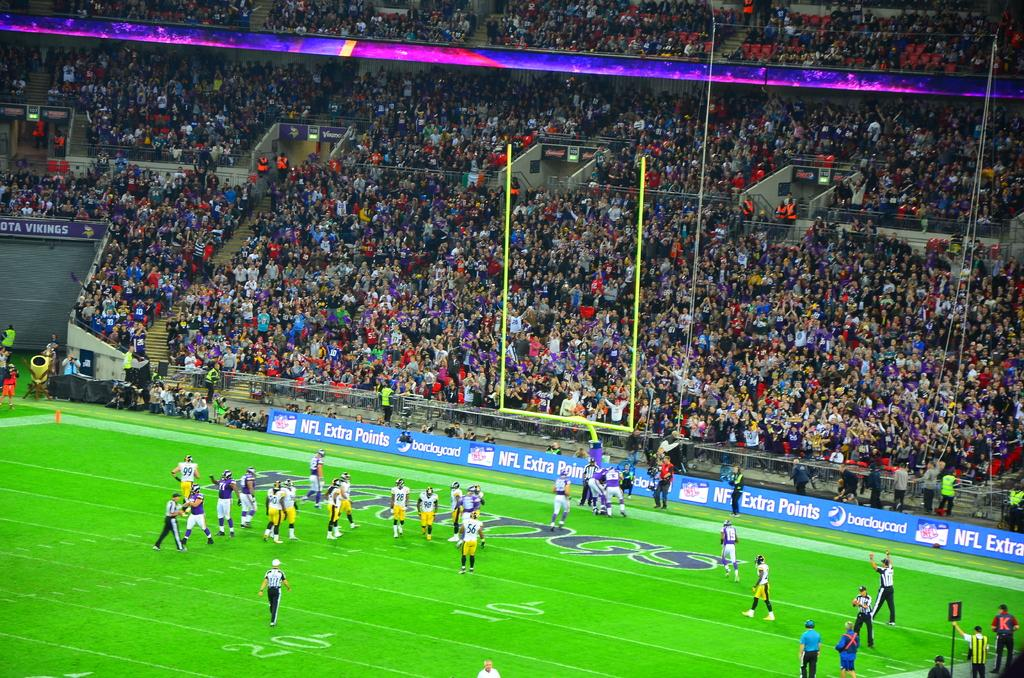<image>
Create a compact narrative representing the image presented. Football players of the field of an NFL stadium. 